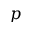<formula> <loc_0><loc_0><loc_500><loc_500>p</formula> 